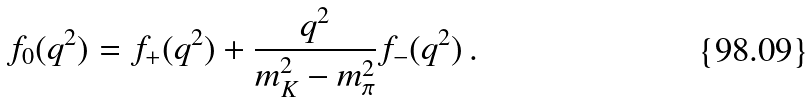Convert formula to latex. <formula><loc_0><loc_0><loc_500><loc_500>f _ { 0 } ( q ^ { 2 } ) = f _ { + } ( q ^ { 2 } ) + \frac { q ^ { 2 } } { m _ { K } ^ { 2 } - m _ { \pi } ^ { 2 } } f _ { - } ( q ^ { 2 } ) \, .</formula> 